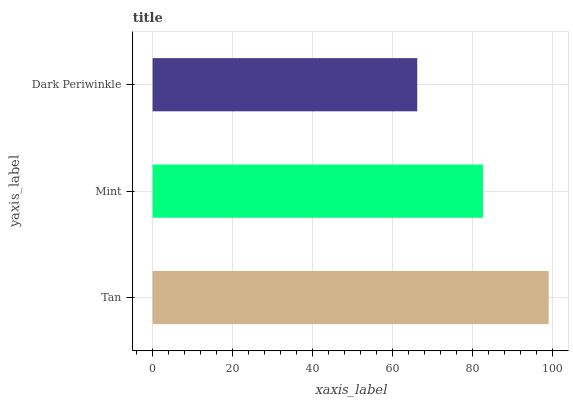Is Dark Periwinkle the minimum?
Answer yes or no. Yes. Is Tan the maximum?
Answer yes or no. Yes. Is Mint the minimum?
Answer yes or no. No. Is Mint the maximum?
Answer yes or no. No. Is Tan greater than Mint?
Answer yes or no. Yes. Is Mint less than Tan?
Answer yes or no. Yes. Is Mint greater than Tan?
Answer yes or no. No. Is Tan less than Mint?
Answer yes or no. No. Is Mint the high median?
Answer yes or no. Yes. Is Mint the low median?
Answer yes or no. Yes. Is Tan the high median?
Answer yes or no. No. Is Tan the low median?
Answer yes or no. No. 